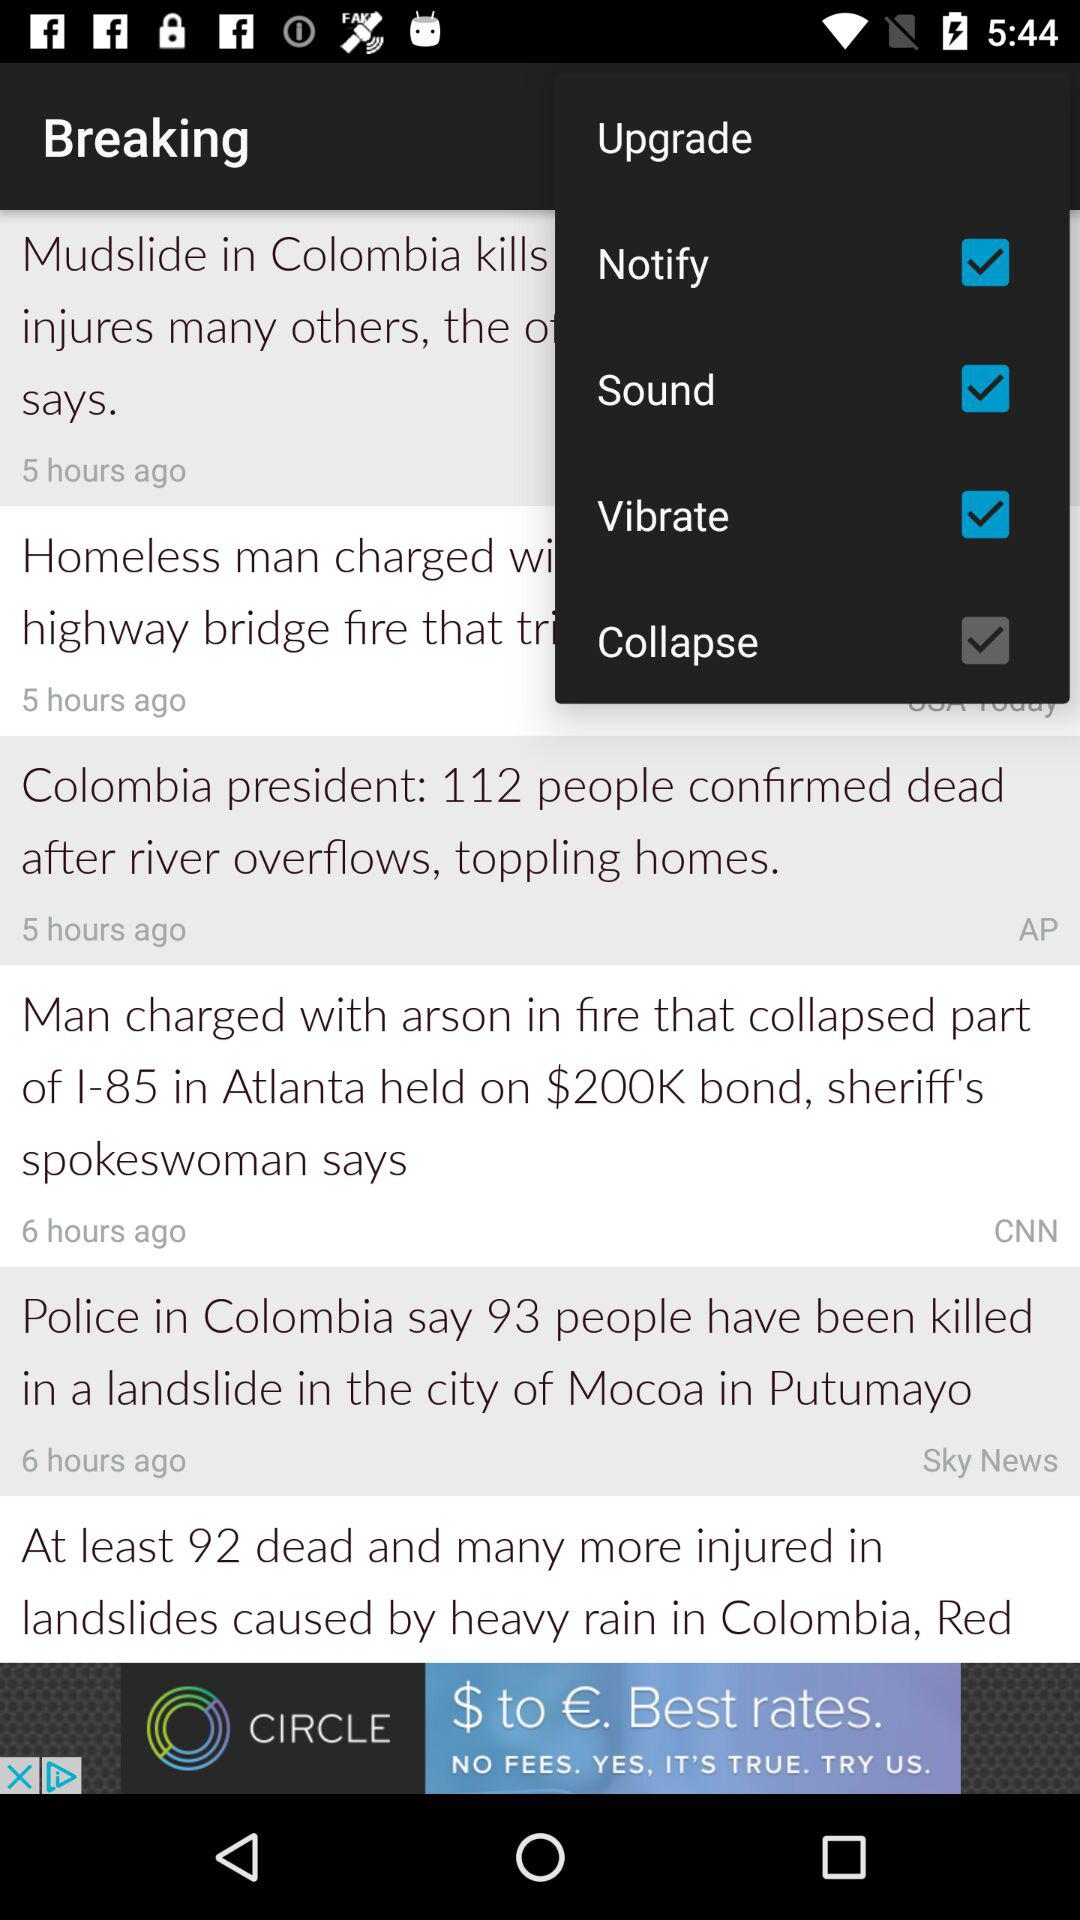Which are the selected options? The selected options are "Notify", "Sound" and "Vibrate". 